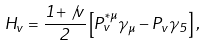Convert formula to latex. <formula><loc_0><loc_0><loc_500><loc_500>H _ { v } = \frac { 1 + \not \, v } { 2 } \left [ P _ { v } ^ { * \mu } \gamma _ { \mu } - P _ { v } \gamma _ { 5 } \right ] ,</formula> 